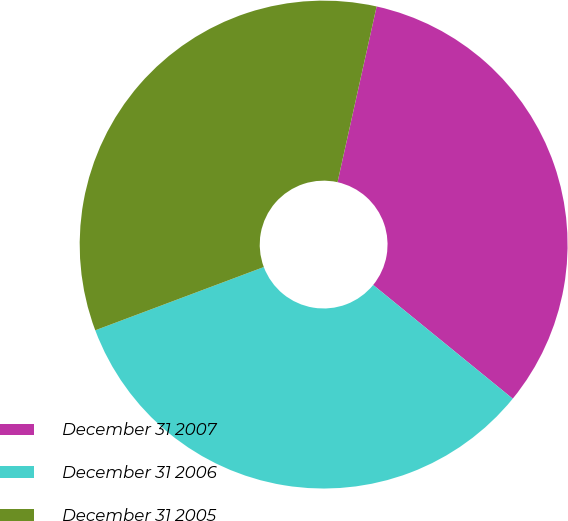<chart> <loc_0><loc_0><loc_500><loc_500><pie_chart><fcel>December 31 2007<fcel>December 31 2006<fcel>December 31 2005<nl><fcel>32.4%<fcel>33.4%<fcel>34.2%<nl></chart> 